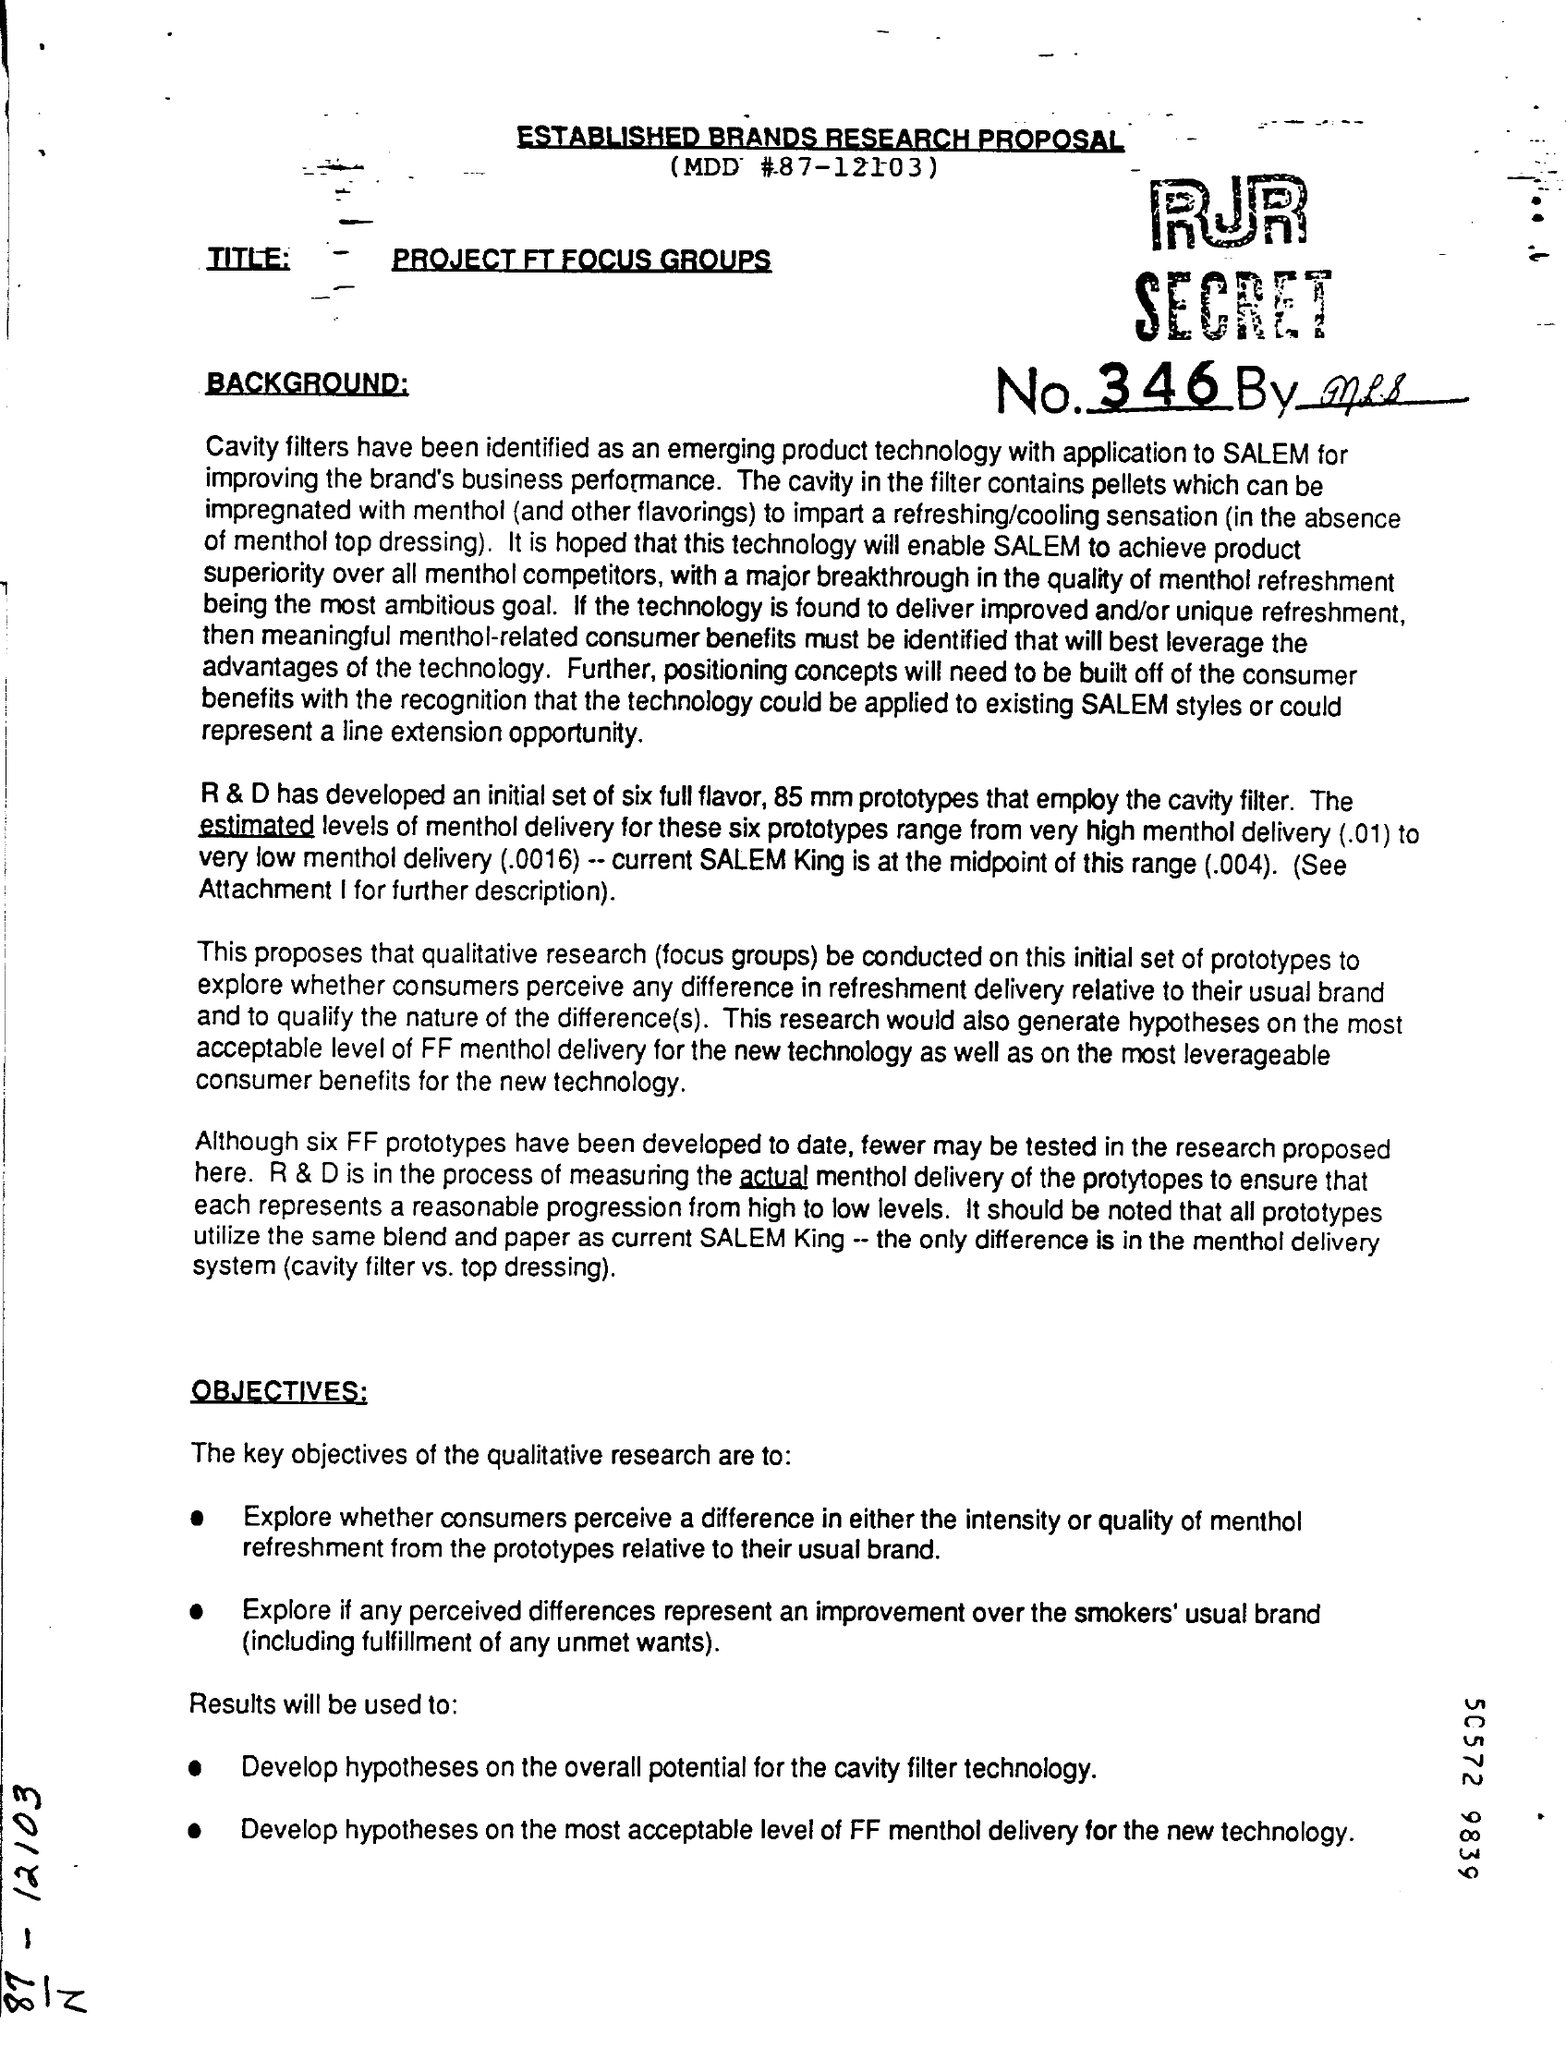Highlight a few significant elements in this photo. The MDD number is 87-12103. 